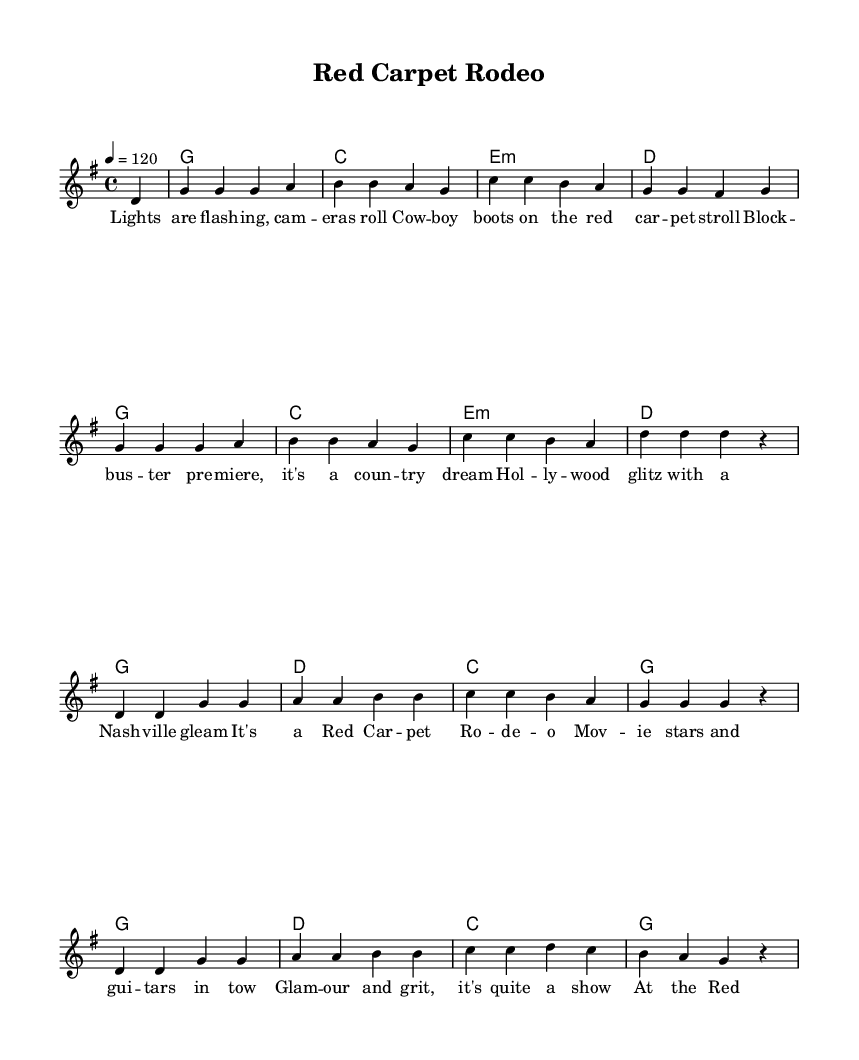What is the key signature of this music? The key signature indicates that the piece is in G major, which contains one sharp (F#). This is determined by looking at the key signature at the beginning of the staff.
Answer: G major What is the time signature of the music? The time signature is shown at the beginning as 4/4, indicating four beats per measure and that the quarter note gets one beat.
Answer: 4/4 What is the tempo marking in this piece? The tempo is indicated at the beginning with "4 = 120," meaning that there are 120 beats per minute, with each beat represented by a quarter note.
Answer: 120 How many measures are in the verse section? By counting the measures in the verse portion of the score, it is clear that there are 4 measures in total before the chorus starts.
Answer: 4 What is the first chord in the verse? The first chord of the verse is indicated in the chord section right above the melody notes, showing it begins with G major.
Answer: G Which music genre does this piece belong to? The overall theme and lyrics, along with the style of the chords and melody, indicate this piece fits within the modern country genre.
Answer: Country What lyrical theme is presented in the chorus? The chorus emphasizes the excitement and glamour of movie premieres and red carpet events, showcasing a fun and celebratory vibe.
Answer: Red Carpet Rodeo 